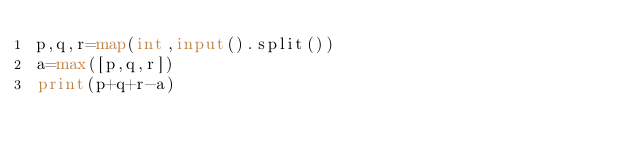Convert code to text. <code><loc_0><loc_0><loc_500><loc_500><_Python_>p,q,r=map(int,input().split())
a=max([p,q,r])
print(p+q+r-a)</code> 